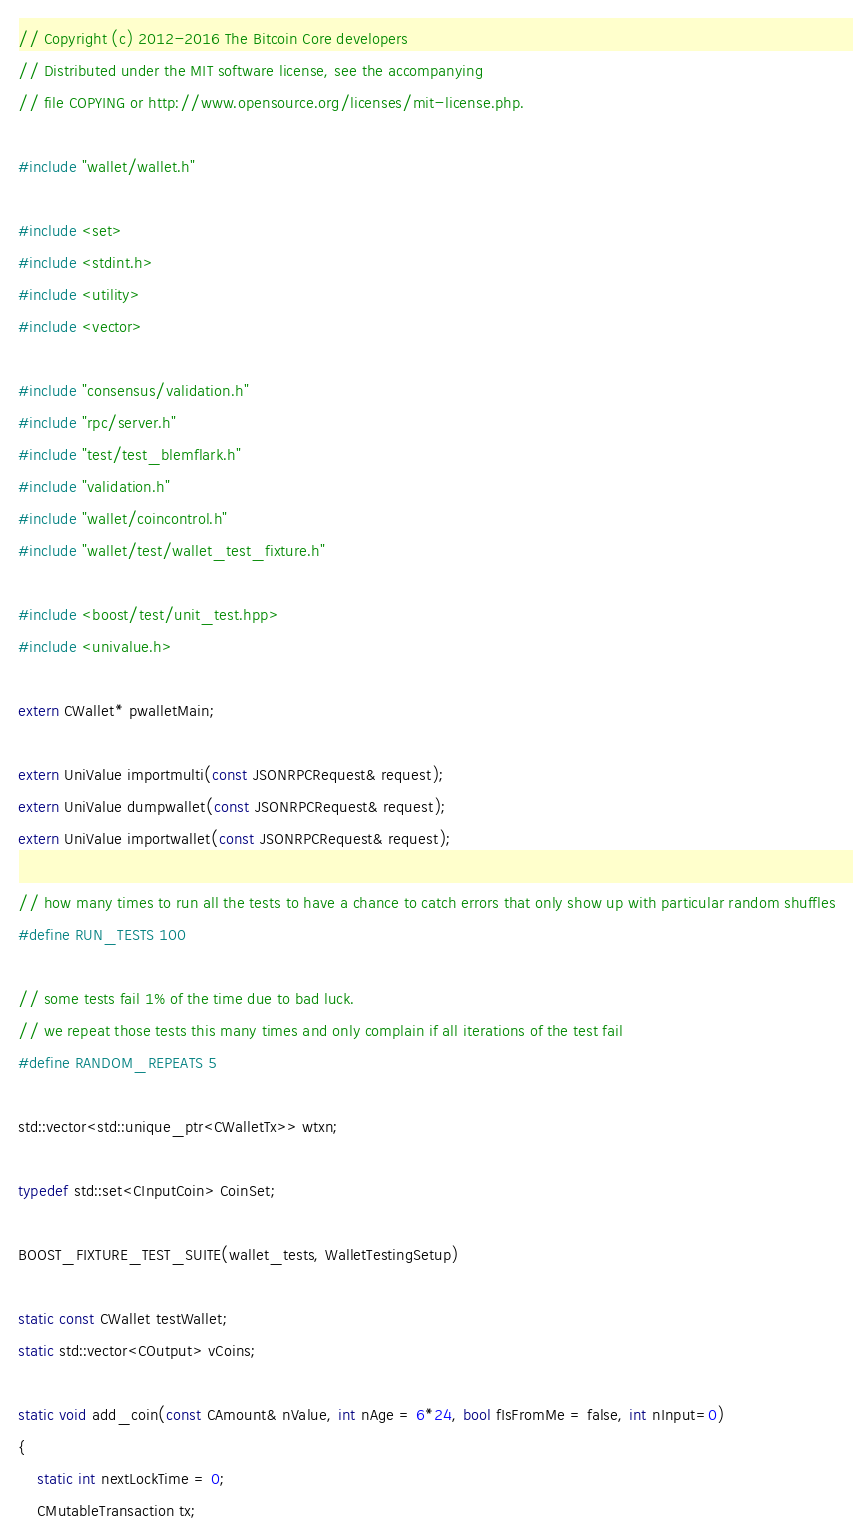<code> <loc_0><loc_0><loc_500><loc_500><_C++_>// Copyright (c) 2012-2016 The Bitcoin Core developers
// Distributed under the MIT software license, see the accompanying
// file COPYING or http://www.opensource.org/licenses/mit-license.php.

#include "wallet/wallet.h"

#include <set>
#include <stdint.h>
#include <utility>
#include <vector>

#include "consensus/validation.h"
#include "rpc/server.h"
#include "test/test_blemflark.h"
#include "validation.h"
#include "wallet/coincontrol.h"
#include "wallet/test/wallet_test_fixture.h"

#include <boost/test/unit_test.hpp>
#include <univalue.h>

extern CWallet* pwalletMain;

extern UniValue importmulti(const JSONRPCRequest& request);
extern UniValue dumpwallet(const JSONRPCRequest& request);
extern UniValue importwallet(const JSONRPCRequest& request);

// how many times to run all the tests to have a chance to catch errors that only show up with particular random shuffles
#define RUN_TESTS 100

// some tests fail 1% of the time due to bad luck.
// we repeat those tests this many times and only complain if all iterations of the test fail
#define RANDOM_REPEATS 5

std::vector<std::unique_ptr<CWalletTx>> wtxn;

typedef std::set<CInputCoin> CoinSet;

BOOST_FIXTURE_TEST_SUITE(wallet_tests, WalletTestingSetup)

static const CWallet testWallet;
static std::vector<COutput> vCoins;

static void add_coin(const CAmount& nValue, int nAge = 6*24, bool fIsFromMe = false, int nInput=0)
{
    static int nextLockTime = 0;
    CMutableTransaction tx;</code> 